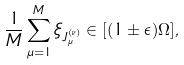<formula> <loc_0><loc_0><loc_500><loc_500>\frac { 1 } { M } \sum _ { \mu = 1 } ^ { M } \xi _ { J ^ { ( \nu ) } _ { \mu } } \in [ ( 1 \pm \epsilon ) \Omega ] ,</formula> 